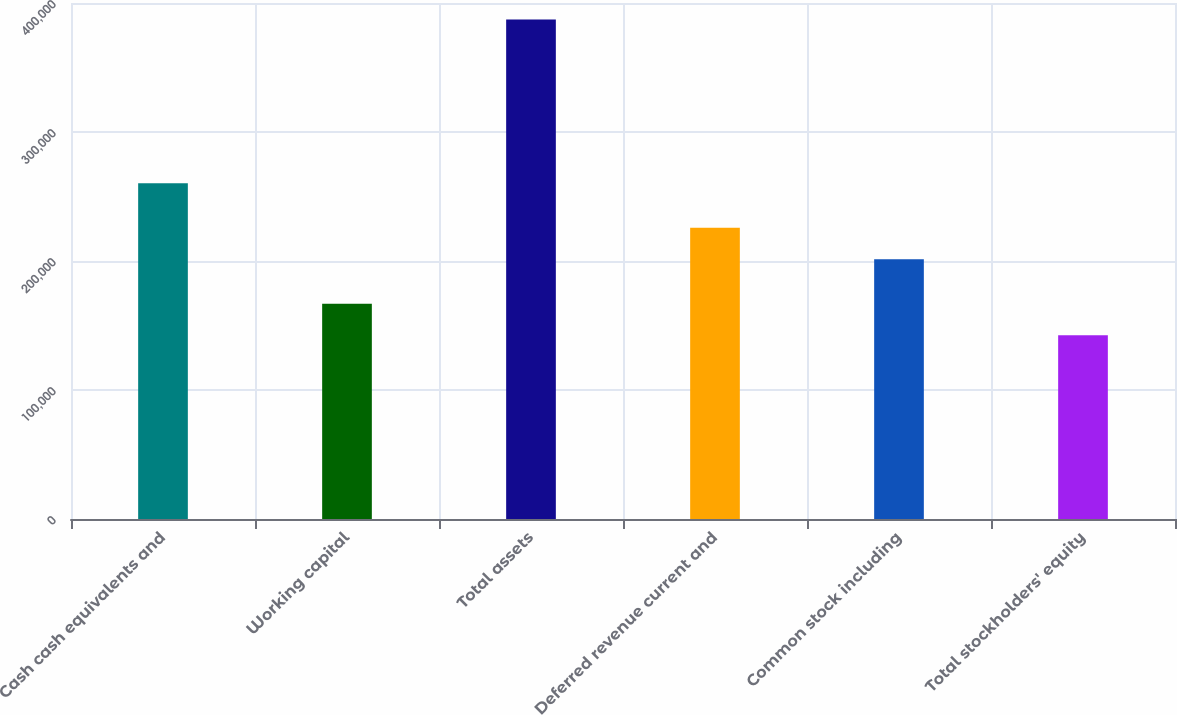<chart> <loc_0><loc_0><loc_500><loc_500><bar_chart><fcel>Cash cash equivalents and<fcel>Working capital<fcel>Total assets<fcel>Deferred revenue current and<fcel>Common stock including<fcel>Total stockholders' equity<nl><fcel>260314<fcel>166928<fcel>387213<fcel>225816<fcel>201340<fcel>142452<nl></chart> 